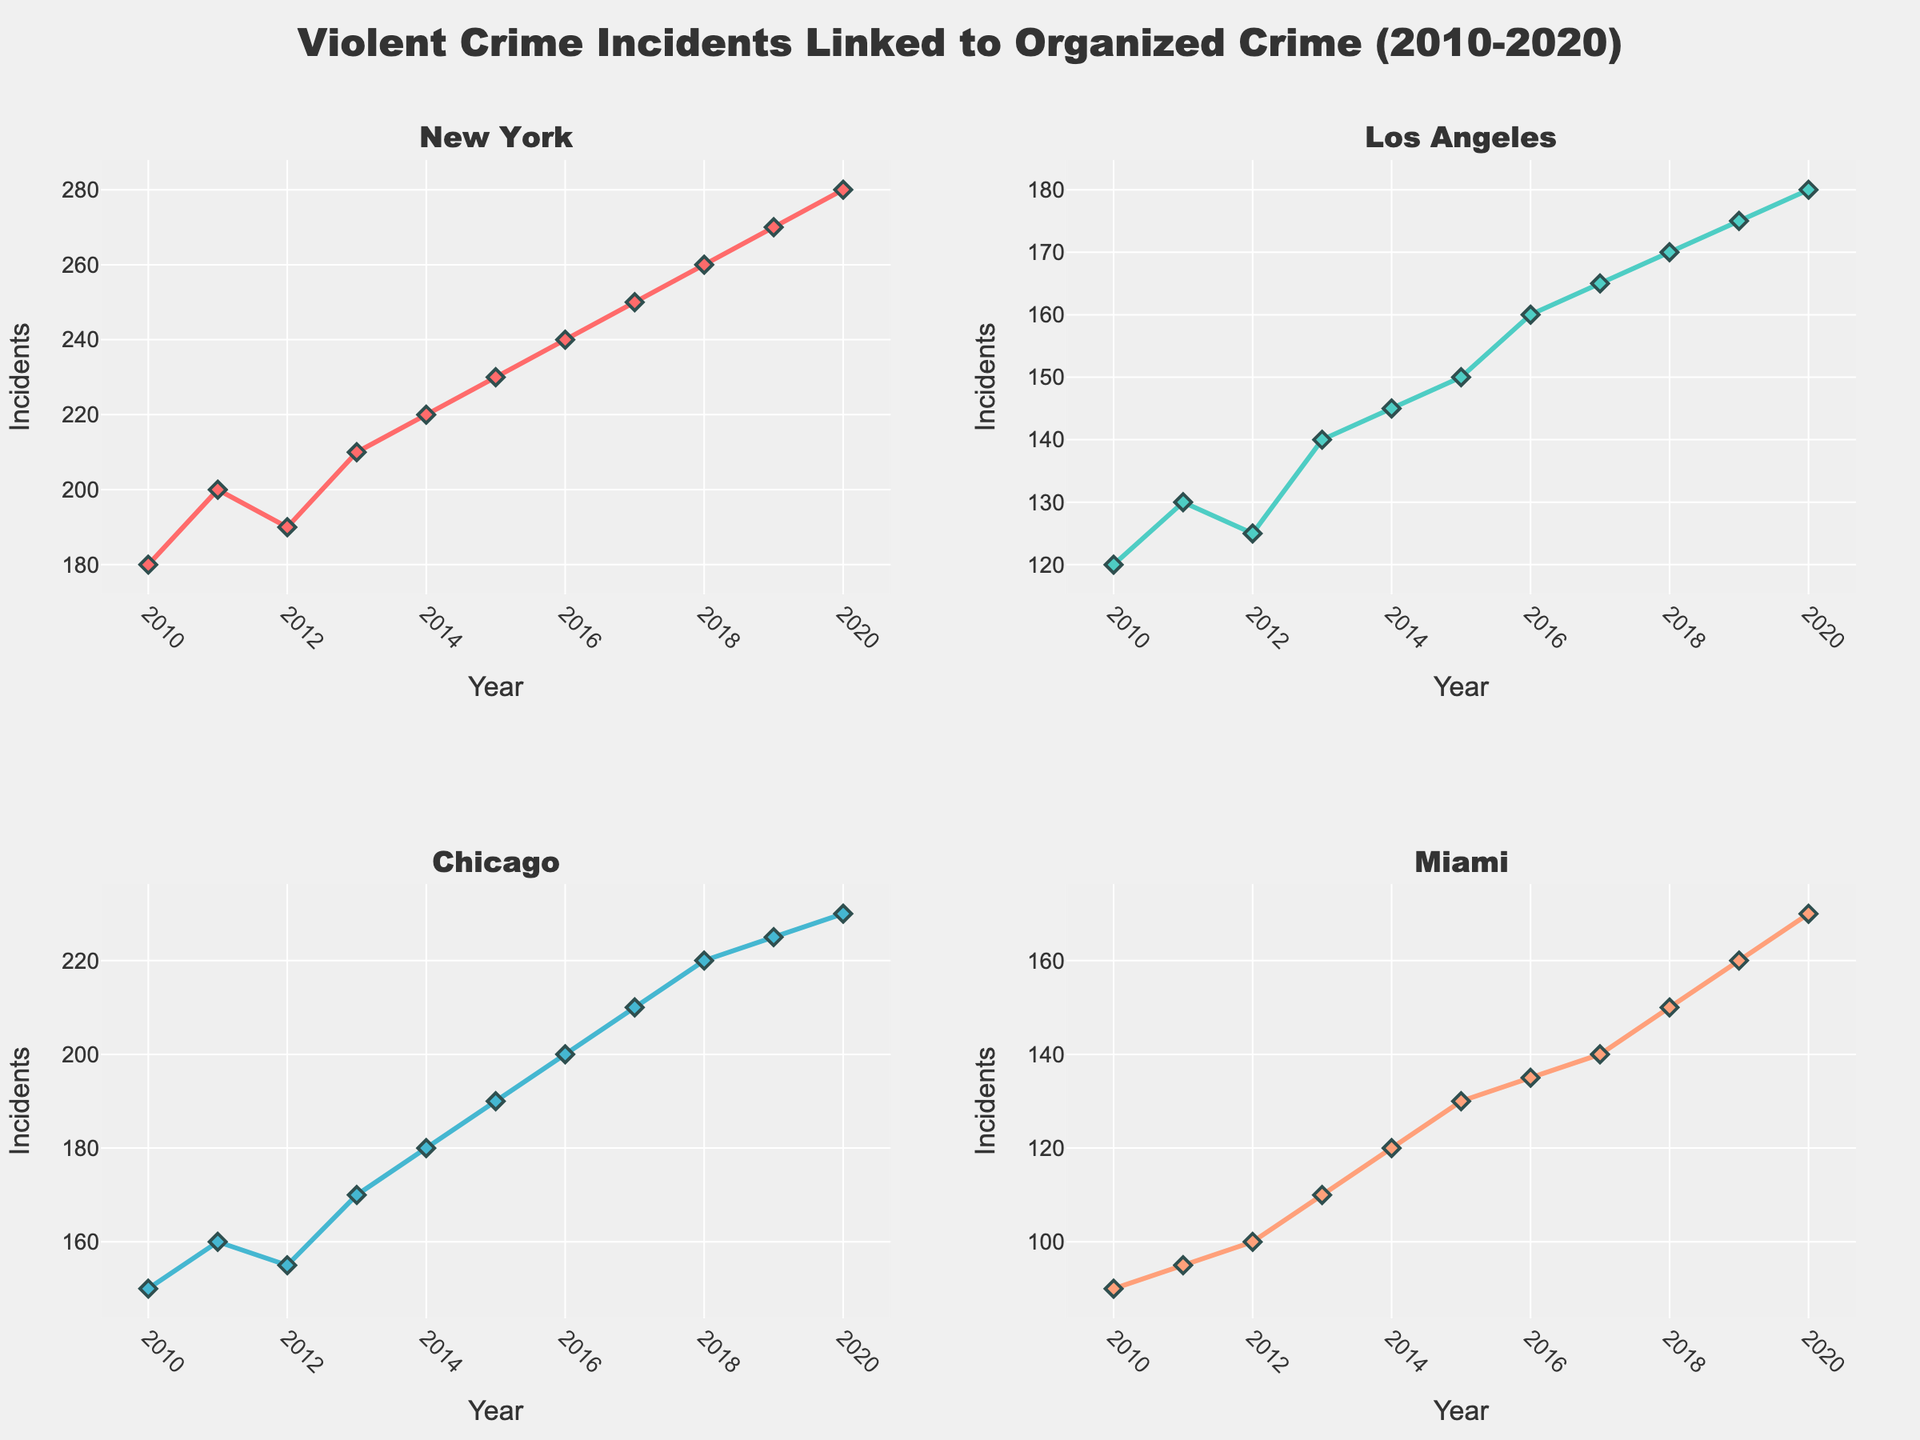What is the title of the figure? The title is usually found at the top of the figure. It summarizes the content of the plot.
Answer: Violent Crime Incidents Linked to Organized Crime (2010-2020) How many regions are compared in the figure? The number of subplots, each with a distinct title indicating the region, provides the information.
Answer: 4 What trend do you observe in violent crime incidents in New York from 2010 to 2020? Observe the line plot in the New York subplot; it shows an increasing trend over the years.
Answer: Increasing Which region had the lowest number of violent crime incidents in 2010? Compare the data points for each region in the year 2010. Miami has the lowest incident count.
Answer: Miami By how much did the incidents increase in Los Angeles from 2010 to 2020? Subtract the number of incidents in 2010 from the number in 2020 as shown in the Los Angeles subplot. 180 (2020) - 120 (2010) = 60
Answer: 60 Which region had the highest increase in violent crime incidents from 2015 to 2020? Calculate the difference for each region between 2015 and 2020, and compare. New York had the highest increase with an increase from 230 (2015) to 280 (2020) = 50.
Answer: New York Are there any years where the number of violent crime incidents decreased instead of increased for any region? Examine each subplot to identify any downward slopes. This pattern is not visible for any of the regions, indicating continuous increase.
Answer: No What is the average number of incidents in Chicago between 2010 and 2020? Sum up the incidents for each year and divide by the number of years (2250 / 11).
Answer: 204.5 Which region had the most consistent rise in the number of violent crime incidents from 2010 to 2020? The consistency of the rise can be judged by the smoothness and linearity of the plot. Miami shows the most consistent rise.
Answer: Miami 